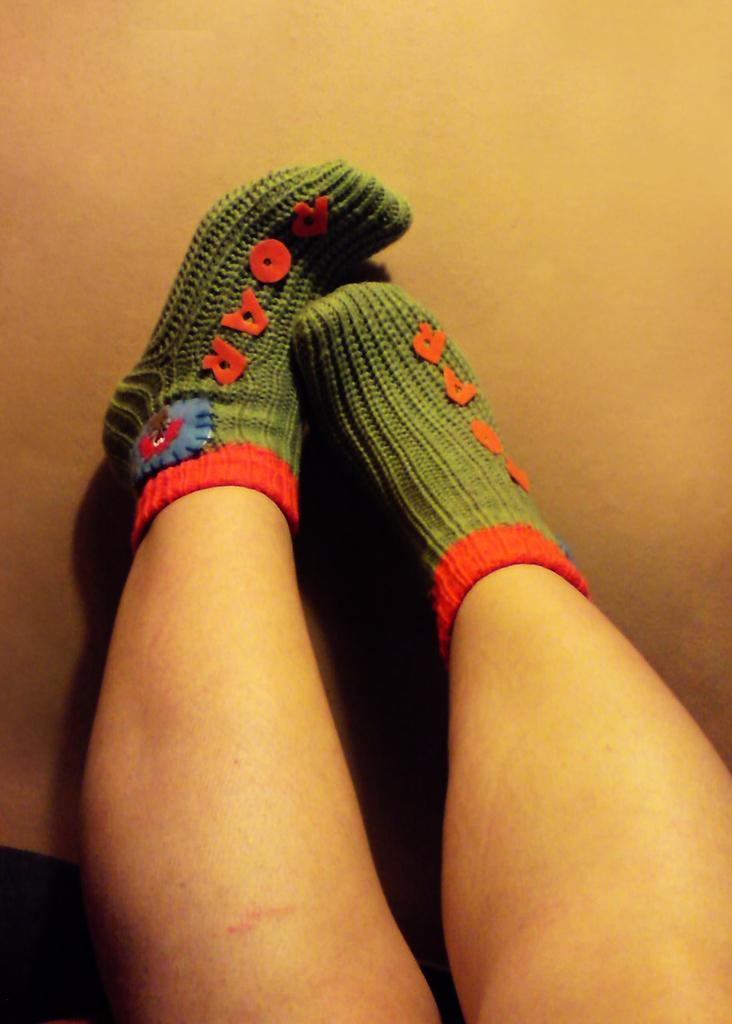Can you describe this image briefly? In this image we can see two legs with green and red color socks. There is one object on the floor, some text with a sticker on the socks. 